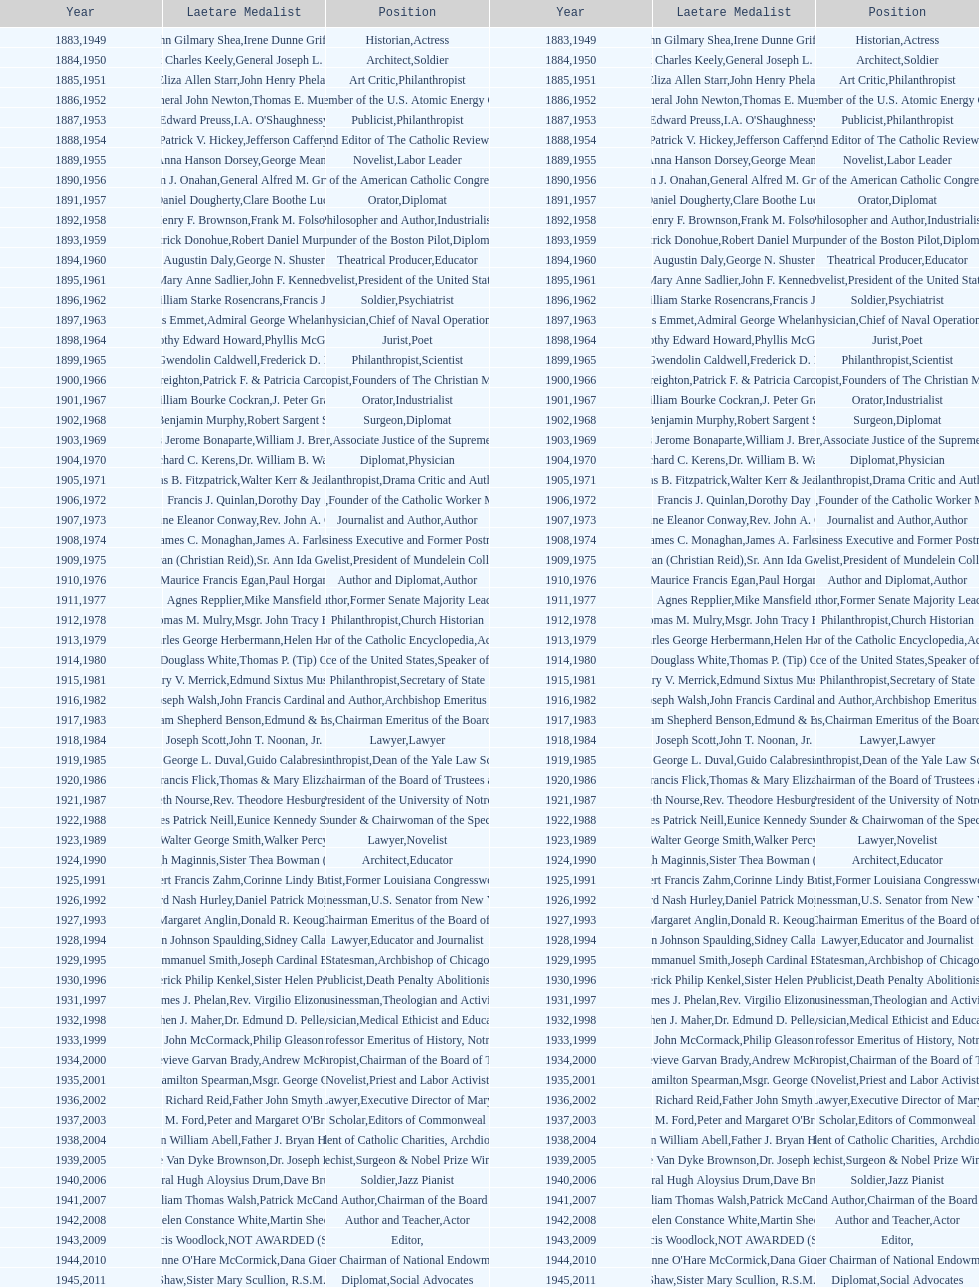What is the count of laetare medal recipients who occupied a diplomatic role? 8. 